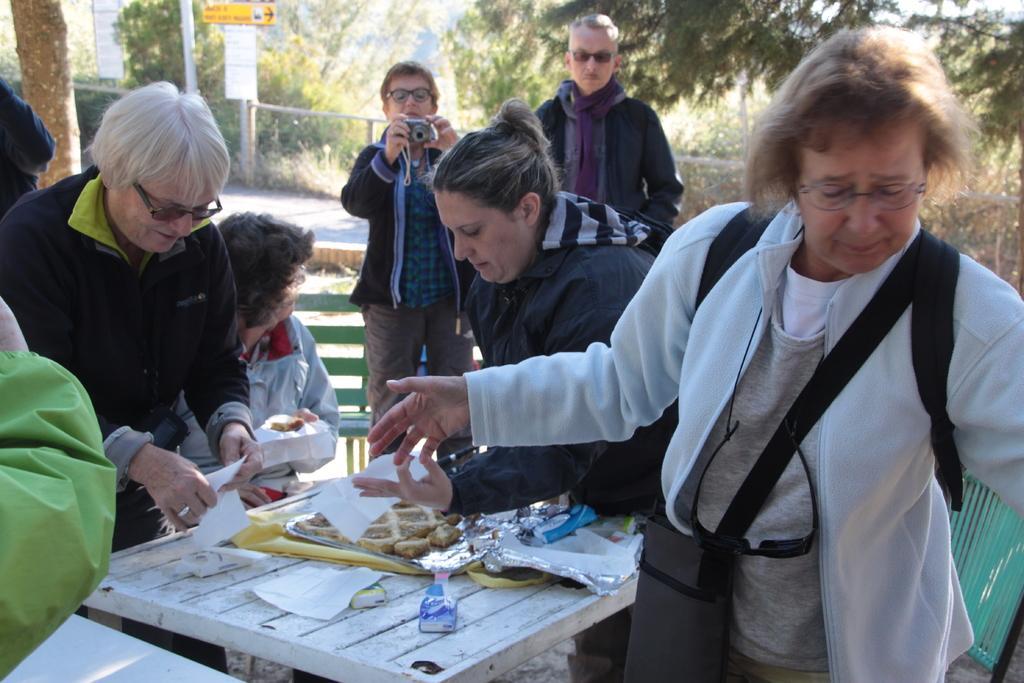Can you describe this image briefly? In this image I can see some people. I can also some objects on the table. In the background, I can see the trees. 